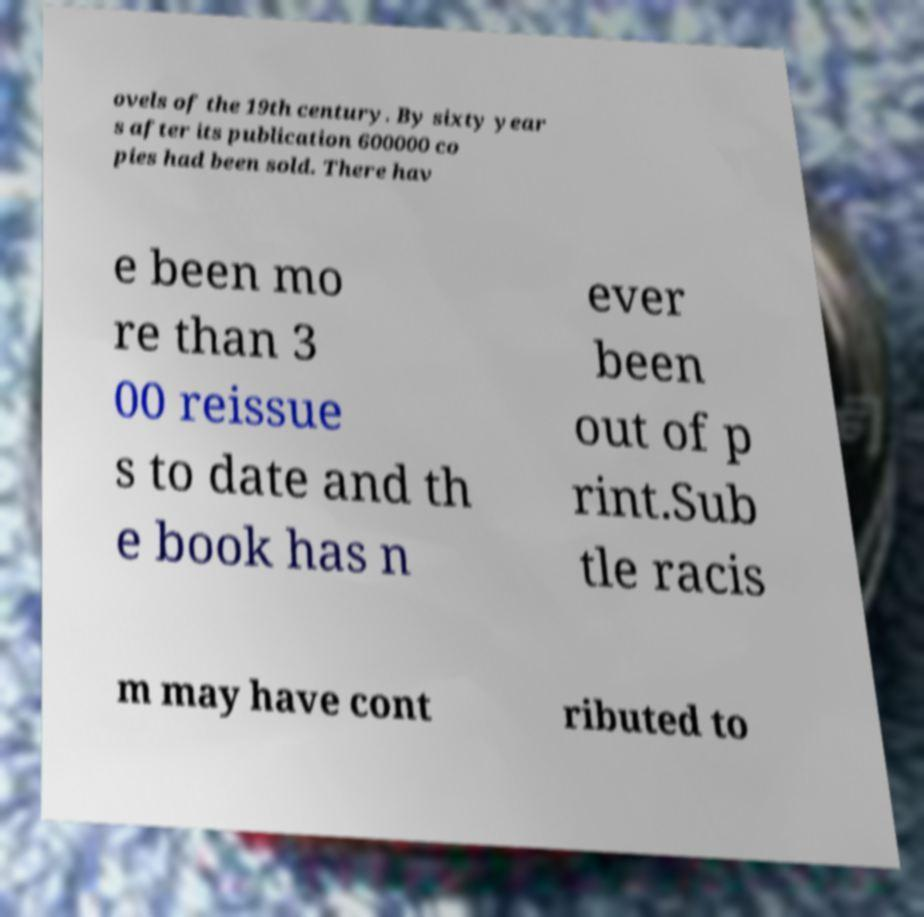Can you accurately transcribe the text from the provided image for me? ovels of the 19th century. By sixty year s after its publication 600000 co pies had been sold. There hav e been mo re than 3 00 reissue s to date and th e book has n ever been out of p rint.Sub tle racis m may have cont ributed to 